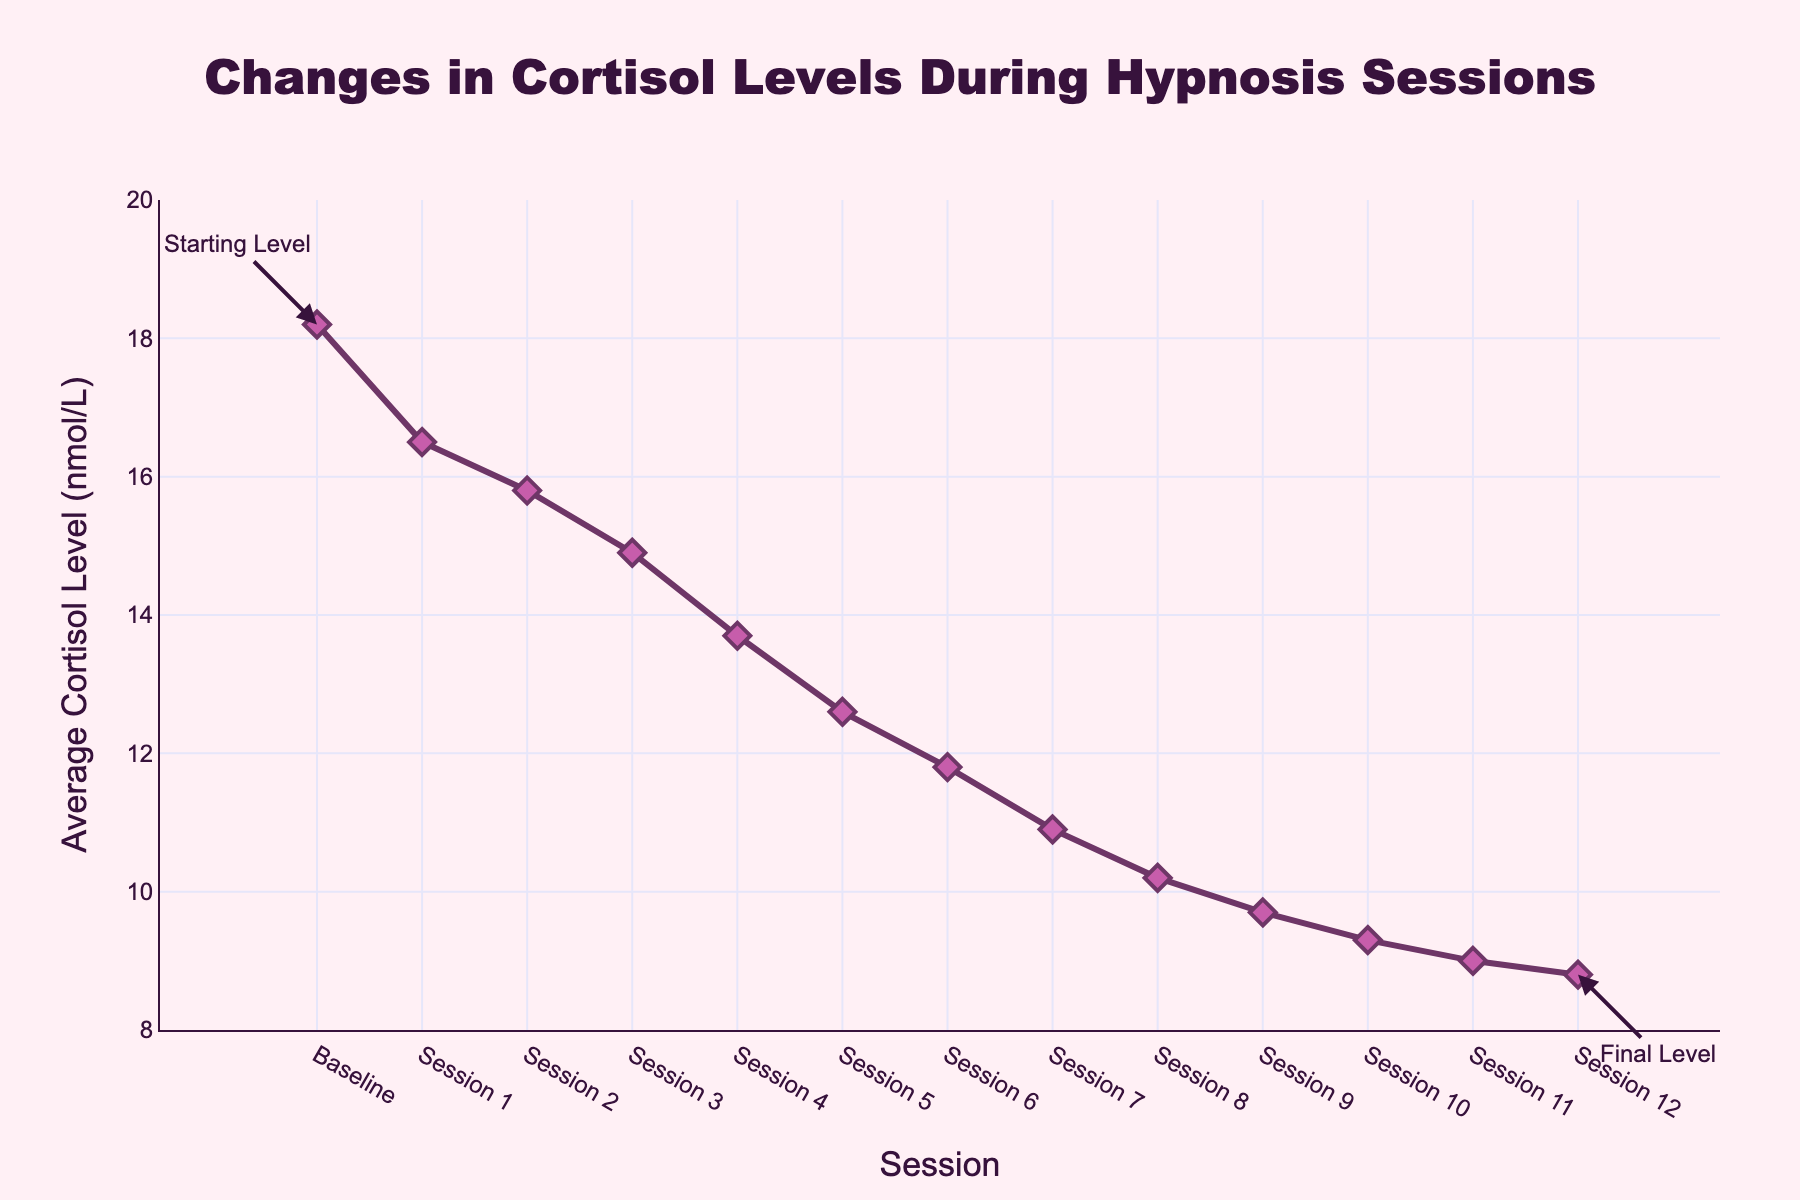What's the baseline cortisol level in nmol/L? Refer to the data point labeled 'Baseline' on the x-axis. The y-value corresponding to 'Baseline' is 18.2 nmol/L.
Answer: 18.2 By how many nmol/L did the cortisol level decrease from Session 1 to Session 3? Find the y-values for Session 1 (16.5 nmol/L) and Session 3 (14.9 nmol/L). Subtract the y-value for Session 3 from the y-value for Session 1. Difference is 16.5 - 14.9 = 1.6 nmol/L.
Answer: 1.6 What is the trend in cortisol levels over the sessions? Observe the plotted line from 'Baseline' to 'Session 12'. The line shows a consistent downward slope, indicating a decrease in cortisol levels over the sessions.
Answer: Decreasing How much did the cortisol level change from the Baseline to Session 12? Find the y-values for 'Baseline' (18.2 nmol/L) and 'Session 12' (8.8 nmol/L). Subtract the y-value for Session 12 from the y-value for Baseline. Change is 18.2 - 8.8 = 9.4 nmol/L.
Answer: 9.4 Which session had an average cortisol level closest to 10 nmol/L? Refer to the y-values corresponding to each session and find the session where the y-value is closest to 10 nmol/L. 'Session 8' has 10.2 nmol/L, which is the closest.
Answer: Session 8 How many sessions are there in total, not including the baseline? Count the number of data points on the x-axis labeled as 'Session' from 'Session 1' to 'Session 12'. There are 12 sessions in total.
Answer: 12 What is the minimum cortisol level recorded during the sessions? Check the y-values for each 'Session' from 'Session 1' to 'Session 12'. The lowest recorded value is 8.8 nmol/L at 'Session 12'.
Answer: 8.8 What is the average change in cortisol levels per session from Baseline to Session 12? Calculate the total decrease in cortisol levels from Baseline (18.2 nmol/L) to Session 12 (8.8 nmol/L), which is 9.4 nmol/L. Divide this by the number of sessions (12). The average change per session is 9.4 / 12 ≈ 0.78 nmol/L per session.
Answer: 0.78 Which session showed the largest single-session decrease in cortisol levels? Compare the change in cortisol levels between consecutive sessions. For example, Session 3 (14.9 nmol/L) to Session 4 (13.7 nmol/L) shows a decrease of 1.2 nmol/L, which is the largest.
Answer: Session 3 to Session 4 